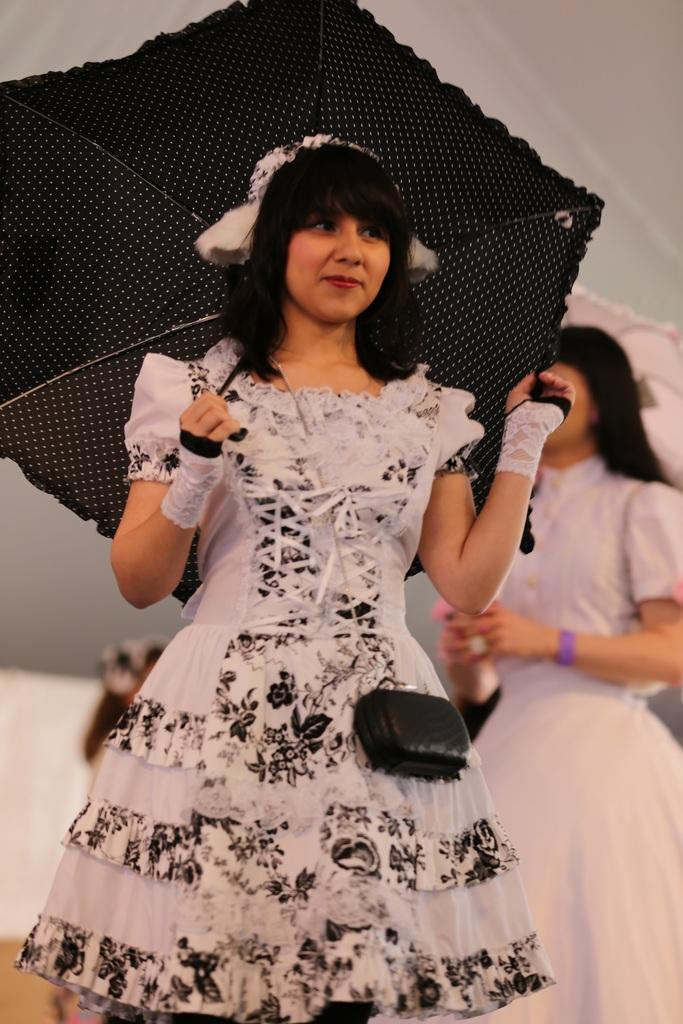What is the main subject in the center of the image? There is a lady holding an umbrella in the center of the image. Can you describe the lady in the background of the image? There is another lady in the background of the image. How many bees are buzzing around the lady holding the umbrella in the image? There are no bees present in the image. What is the size of the umbrella being held by the lady in the image? The size of the umbrella cannot be determined from the image alone, as there is no reference point for comparison. 